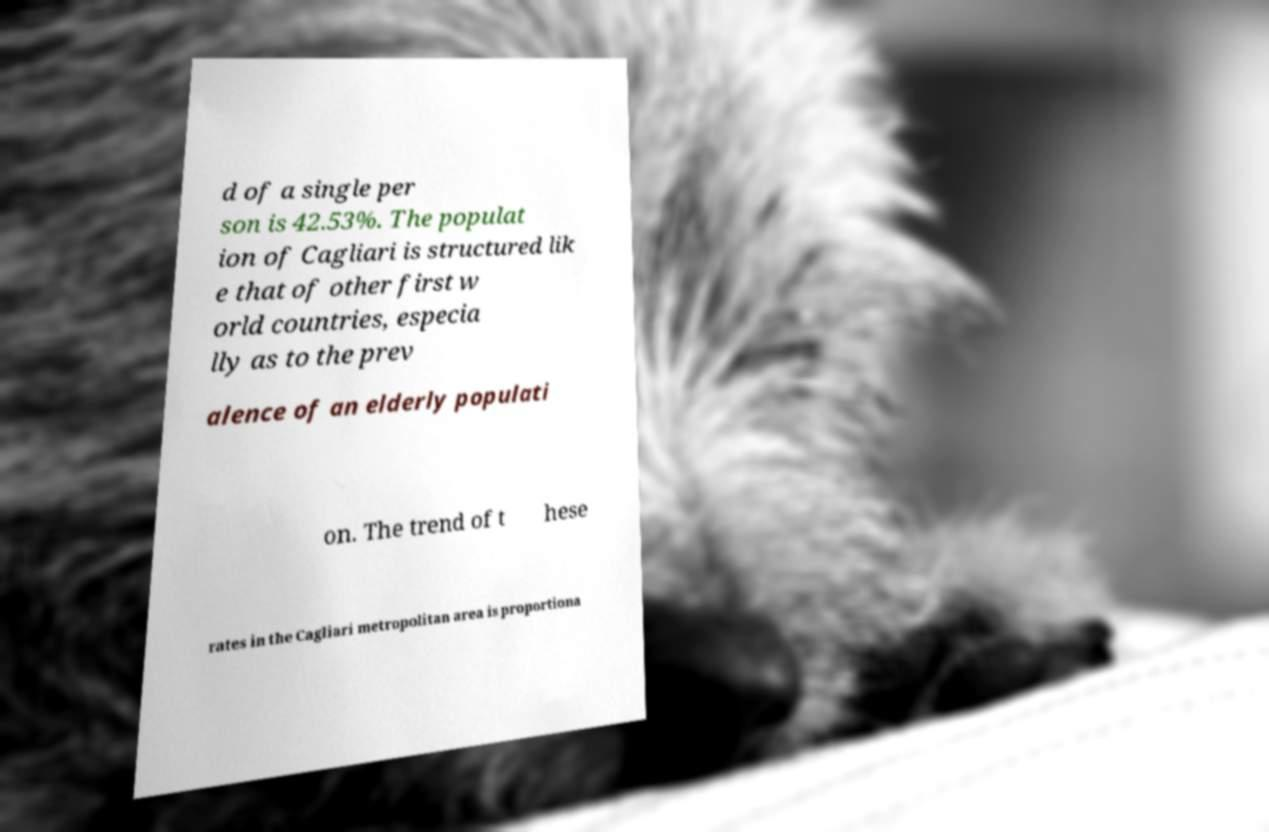Please identify and transcribe the text found in this image. d of a single per son is 42.53%. The populat ion of Cagliari is structured lik e that of other first w orld countries, especia lly as to the prev alence of an elderly populati on. The trend of t hese rates in the Cagliari metropolitan area is proportiona 